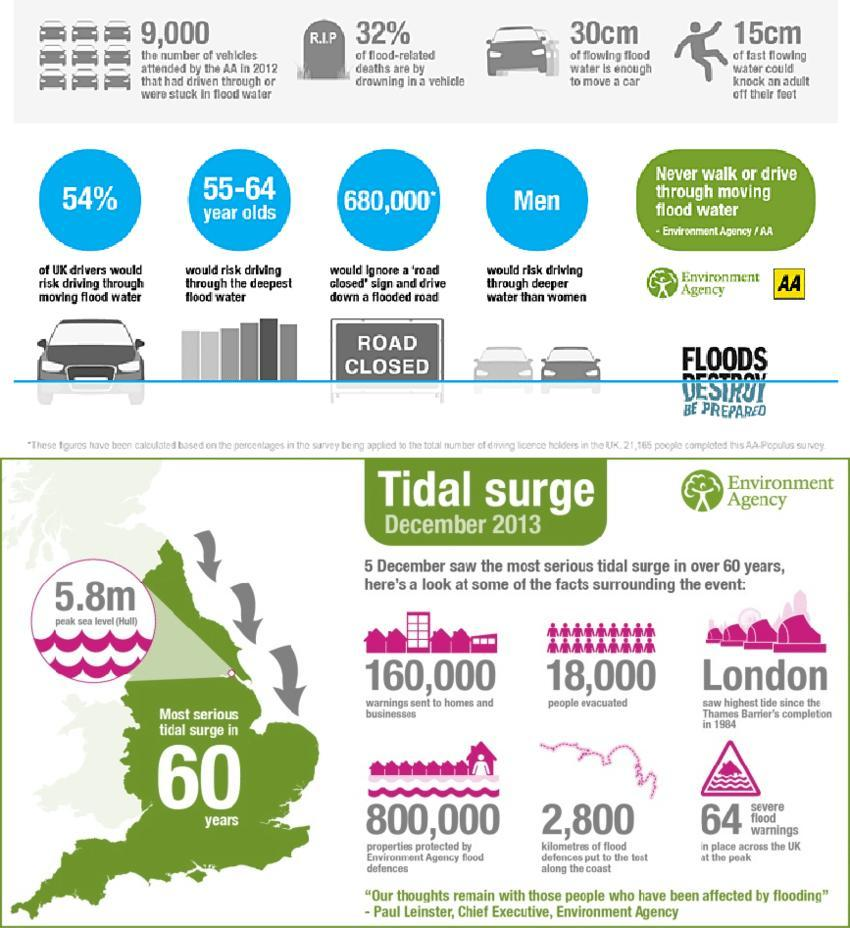What height of fast flowing water could knock an adult of their feet?
Answer the question with a short phrase. 15cm Who would risk driving through deeper water, women or men? men How many severe flood warnings where in place across UK at the peak? 64 What height of flowing flood water is enough to move a car? 30cm How many properties were protected by environment agency flood defences? 800,000 How many warnings were sent to homes  and businesses? 160,000 What percentage of UK drivers would risk driving through moving flood water? 54% How many people would ignore a "road closed"  sign and drive down a flooded road? 680,000 How many vehicles had driven through or were stuck in flood waters in 2012? 9,000 How many people were evacuated due to the tidal surge in December 2013? 18,000 What percentage of flood related deaths are by drowning in a vehicle? 32% 